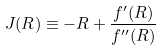Convert formula to latex. <formula><loc_0><loc_0><loc_500><loc_500>J ( R ) \equiv - R + \frac { f ^ { \prime } ( R ) } { f ^ { \prime \prime } ( R ) }</formula> 